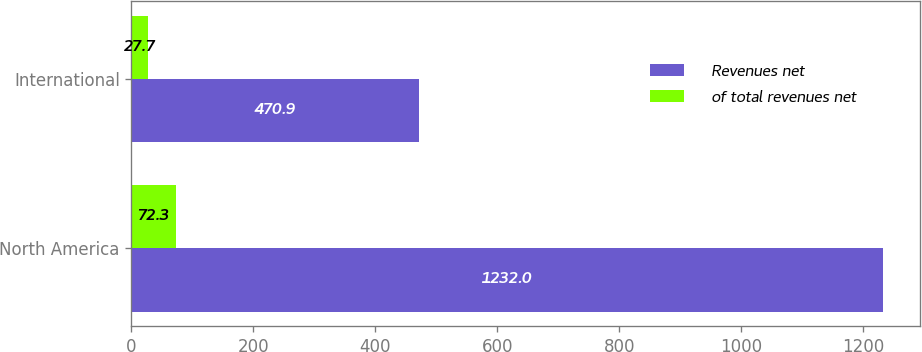<chart> <loc_0><loc_0><loc_500><loc_500><stacked_bar_chart><ecel><fcel>North America<fcel>International<nl><fcel>Revenues net<fcel>1232<fcel>470.9<nl><fcel>of total revenues net<fcel>72.3<fcel>27.7<nl></chart> 